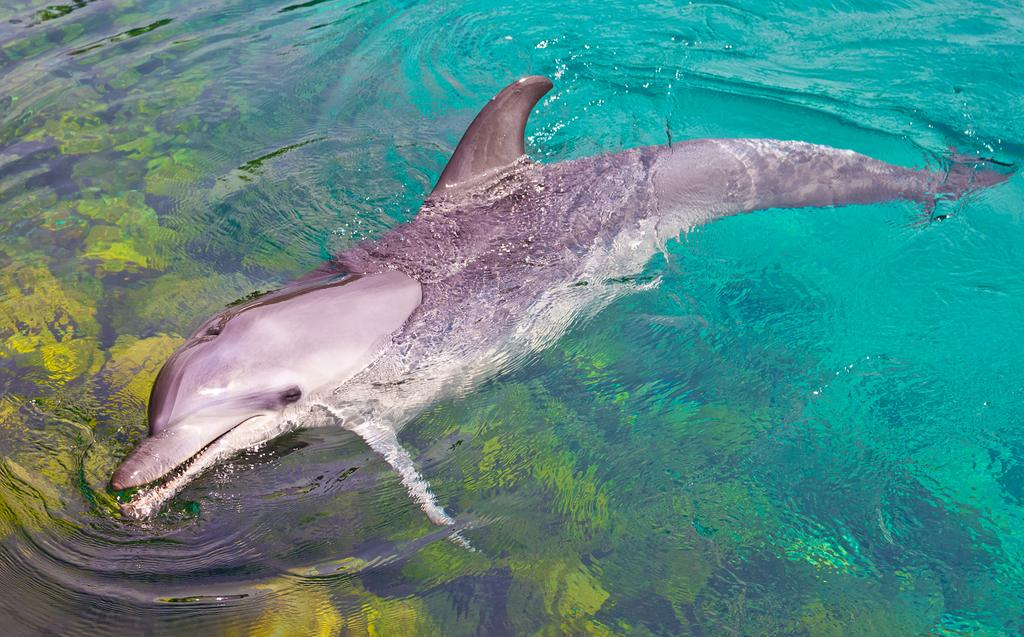What animal can be seen in the image? There is a dolphin in the water. Where is the dolphin located in relation to the image? The dolphin is in the foreground of the image. What type of stitch is being used to sew the river in the image? There is no river or stitching present in the image; it features a dolphin in the water. What is the source of the shock experienced by the dolphin in the image? There is no shock or indication of any electrical activity in the image; it simply shows a dolphin in the water. 